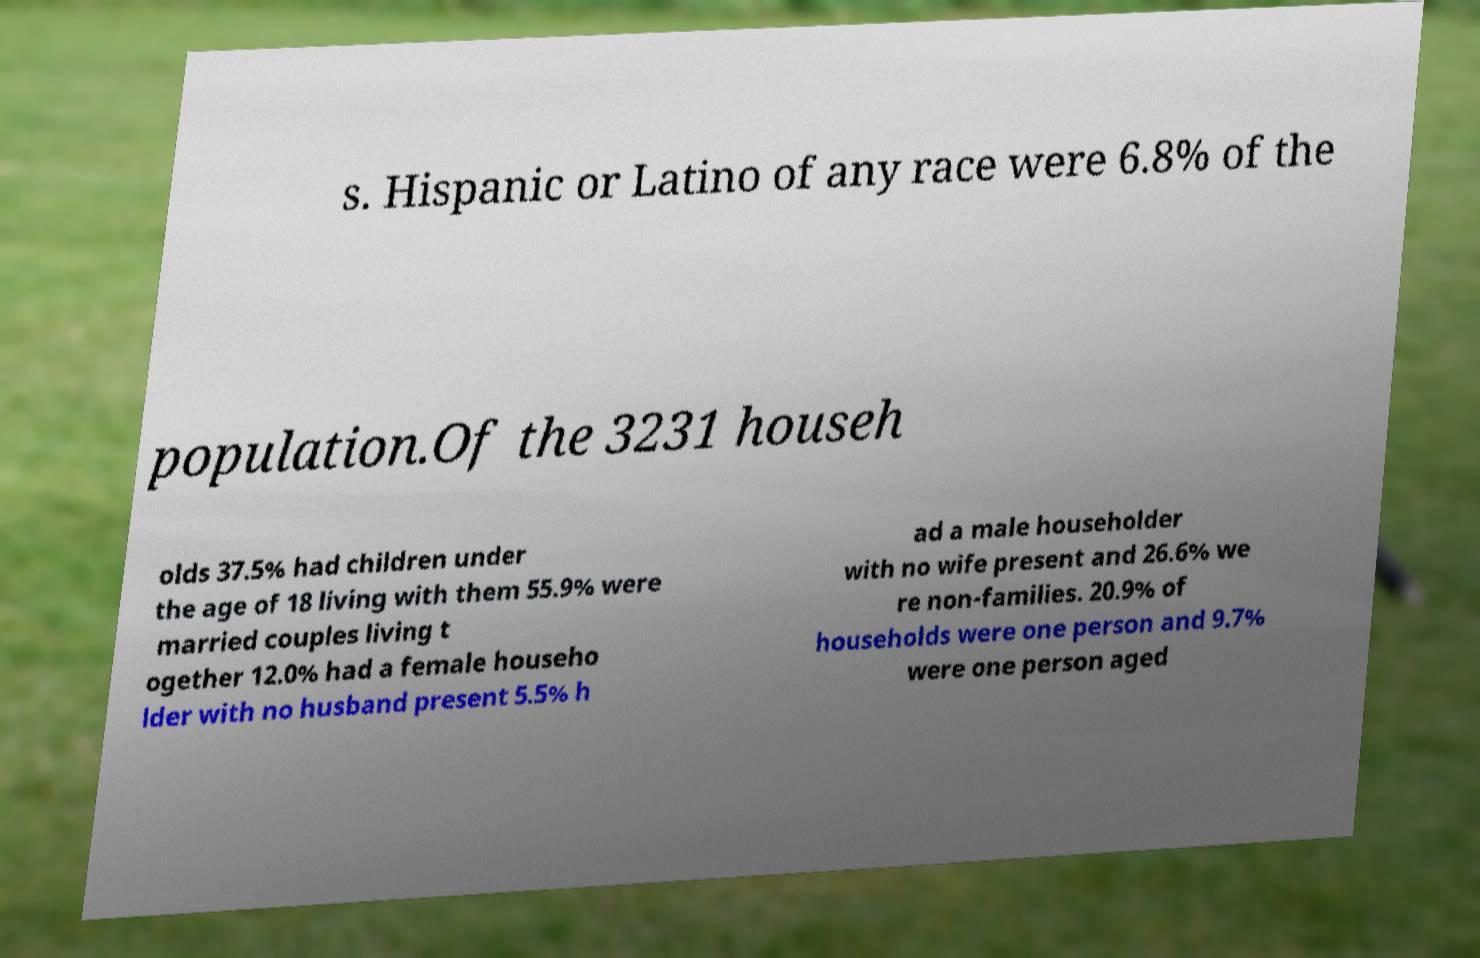For documentation purposes, I need the text within this image transcribed. Could you provide that? s. Hispanic or Latino of any race were 6.8% of the population.Of the 3231 househ olds 37.5% had children under the age of 18 living with them 55.9% were married couples living t ogether 12.0% had a female househo lder with no husband present 5.5% h ad a male householder with no wife present and 26.6% we re non-families. 20.9% of households were one person and 9.7% were one person aged 